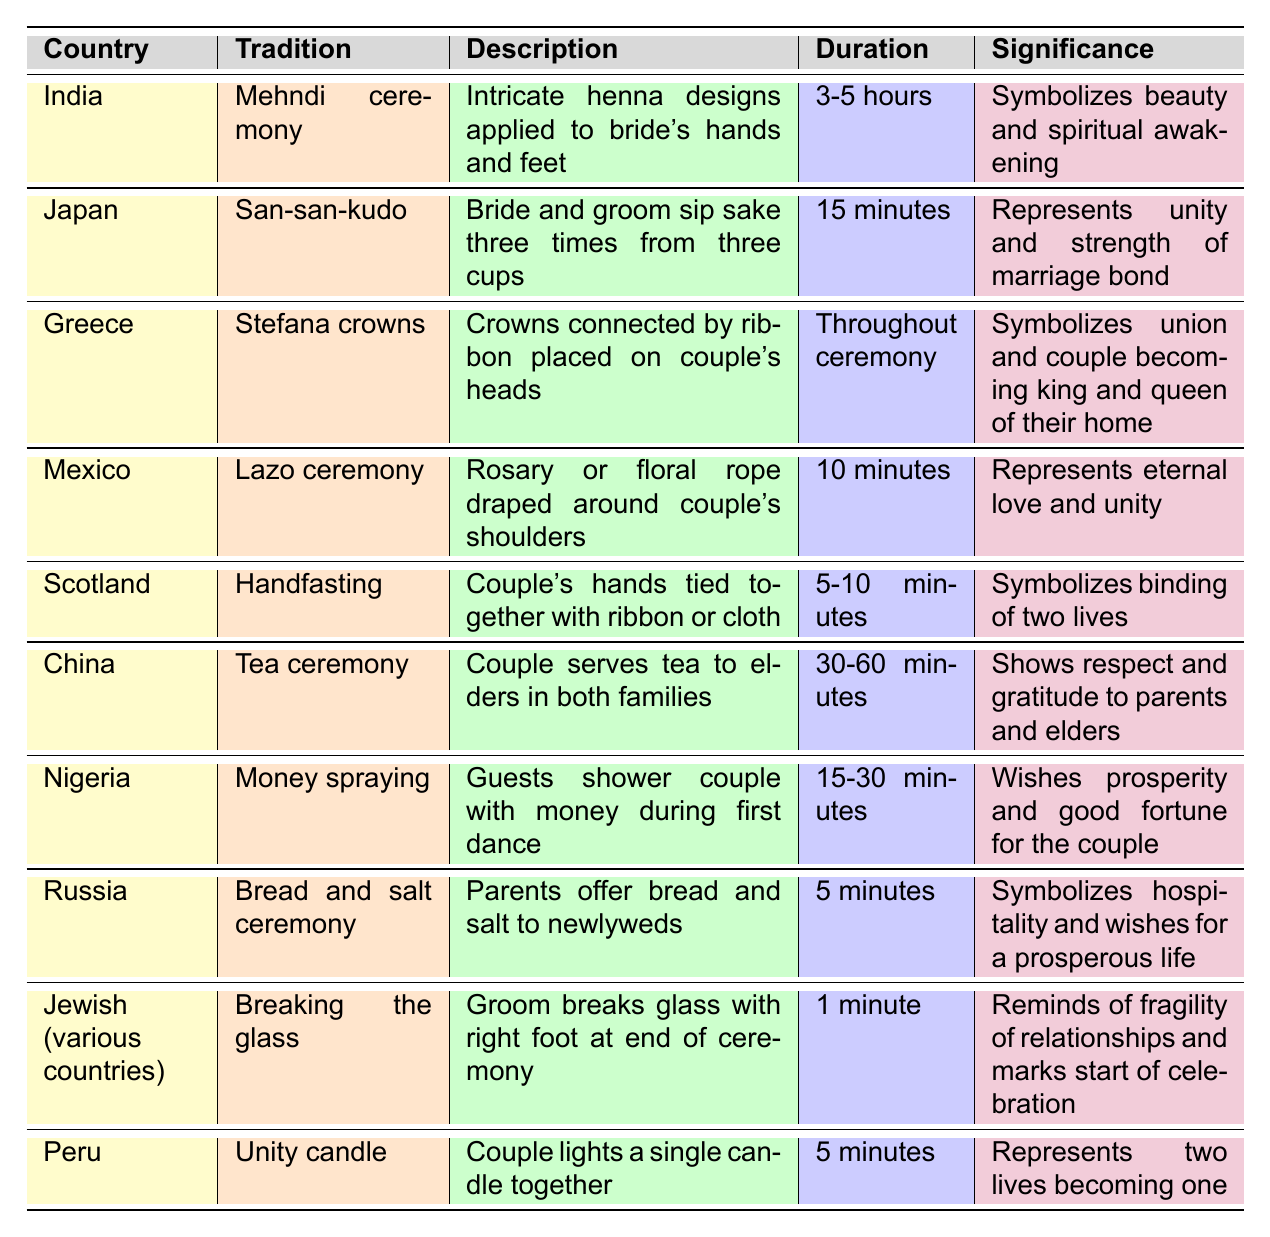What is the significance of the Mehndi ceremony in India? The Mehndi ceremony symbolizes beauty and spiritual awakening according to the table.
Answer: It symbolizes beauty and spiritual awakening How long does the Money spraying tradition in Nigeria last? The table indicates that the duration of the Money spraying tradition is between 15 to 30 minutes.
Answer: 15-30 minutes Which wedding tradition has the longest duration? By comparing the durations in the table, the Mehndi ceremony in India lasts 3-5 hours, which is the longest.
Answer: Mehndi ceremony Is the Tea ceremony specific to China? Yes, according to the table, the Tea ceremony is specifically noted as a tradition observed in China.
Answer: Yes How many traditions last less than 10 minutes according to the table? The table shows that the Bread and salt ceremony lasts 5 minutes, and Breaking the glass lasts 1 minute, making a total of 2 traditions.
Answer: 2 traditions What is the main purpose of the Lazo ceremony in Mexico? The table states that the Lazo ceremony represents eternal love and unity, making this its main purpose.
Answer: Eternal love and unity Are there any traditions that last exactly 5 minutes? Yes, both the Bread and salt ceremony and the Unity candle tradition last exactly 5 minutes according to the table.
Answer: Yes Which tradition emphasizes unity by drinking from three cups? The San-san-kudo tradition in Japan emphasizes unity by having the bride and groom sip sake three times from three cups.
Answer: San-san-kudo What is the common theme among the significance of the Tea ceremony and the Bread and salt ceremony? Both traditions emphasize respect and wishes for a prosperous life. The Tea ceremony shows respect to elders while the Bread and salt ceremony represents hospitality.
Answer: Respect and prosperous life Which wedding tradition involves the couple lighting a candle? The Unity candle tradition in Peru involves the couple lighting a single candle together.
Answer: Unity candle 